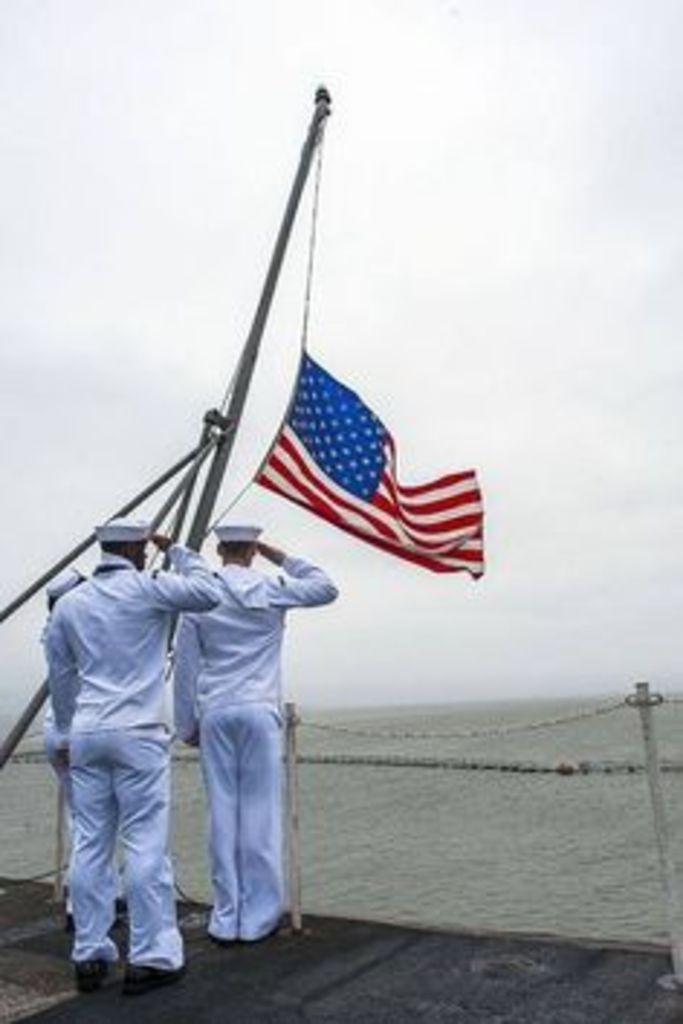Please provide a concise description of this image. In this image we can see the people standing on the ground and saluting. We can see a flag with a rod. In front of them, we can see the water, sky and sticks with ropes. 